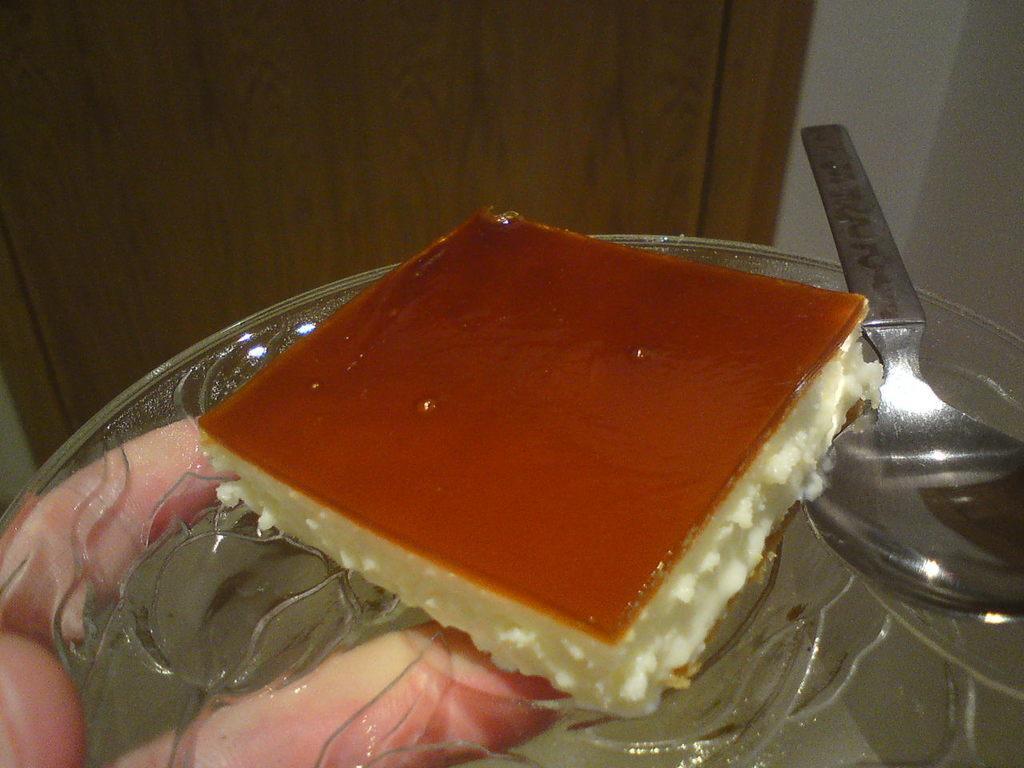How would you summarize this image in a sentence or two? In this image we can see the hand of a person holding a plate containing some food and a spoon in it. On the backside we can see a door and a wall. 